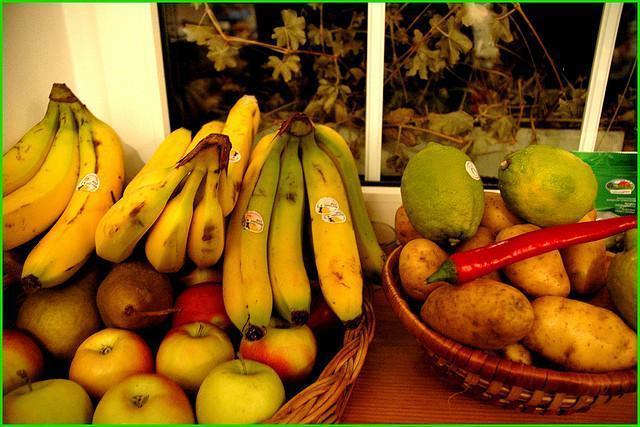How many limes are there?
Give a very brief answer. 2. How many bunches of bananas are pictured?
Give a very brief answer. 3. How many bowls are there?
Give a very brief answer. 2. How many bananas can you see?
Give a very brief answer. 2. How many apples can you see?
Give a very brief answer. 2. 